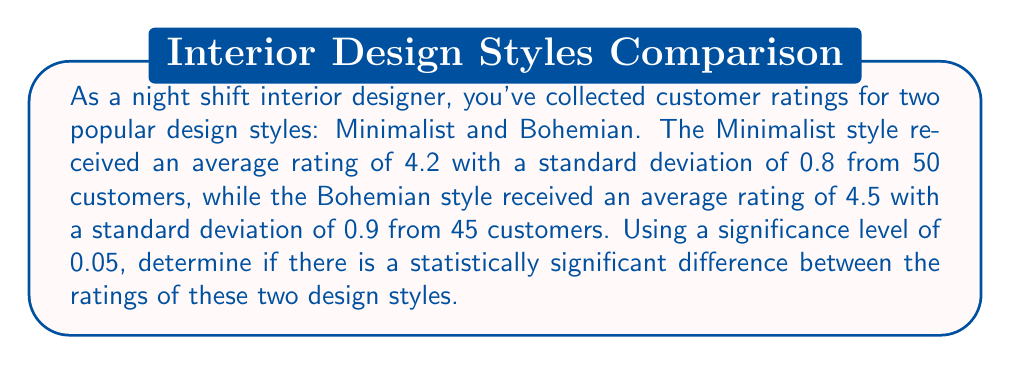Can you answer this question? To determine if there's a statistically significant difference between the ratings, we'll use a two-sample t-test. Here are the steps:

1. State the null and alternative hypotheses:
   $H_0: \mu_1 = \mu_2$ (no difference in mean ratings)
   $H_a: \mu_1 \neq \mu_2$ (there is a difference in mean ratings)

2. Calculate the pooled standard error:
   $$SE = \sqrt{\frac{s_1^2}{n_1} + \frac{s_2^2}{n_2}}$$
   $$SE = \sqrt{\frac{0.8^2}{50} + \frac{0.9^2}{45}} = 0.1796$$

3. Calculate the t-statistic:
   $$t = \frac{\bar{x}_1 - \bar{x}_2}{SE} = \frac{4.2 - 4.5}{0.1796} = -1.67$$

4. Determine the degrees of freedom:
   $$df = n_1 + n_2 - 2 = 50 + 45 - 2 = 93$$

5. Find the critical t-value for a two-tailed test with α = 0.05 and df = 93:
   $t_{critical} = \pm 1.986$ (from t-distribution table)

6. Compare the calculated t-statistic to the critical value:
   $|-1.67| < 1.986$

7. Calculate the p-value:
   Using a t-distribution calculator, we find that the p-value for t = -1.67 and df = 93 is approximately 0.0984.

Since the absolute value of our calculated t-statistic is less than the critical value, and the p-value (0.0984) is greater than our significance level (0.05), we fail to reject the null hypothesis.
Answer: No statistically significant difference (p = 0.0984 > 0.05) 